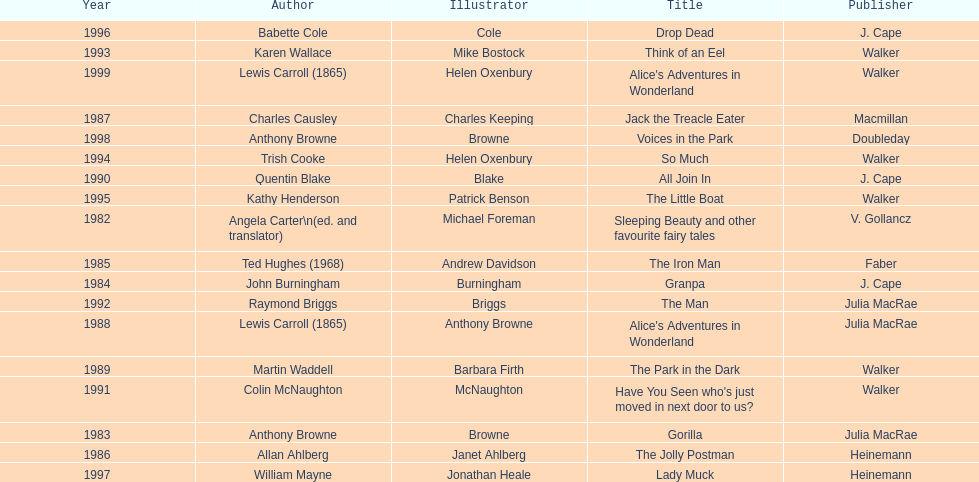Can you parse all the data within this table? {'header': ['Year', 'Author', 'Illustrator', 'Title', 'Publisher'], 'rows': [['1996', 'Babette Cole', 'Cole', 'Drop Dead', 'J. Cape'], ['1993', 'Karen Wallace', 'Mike Bostock', 'Think of an Eel', 'Walker'], ['1999', 'Lewis Carroll (1865)', 'Helen Oxenbury', "Alice's Adventures in Wonderland", 'Walker'], ['1987', 'Charles Causley', 'Charles Keeping', 'Jack the Treacle Eater', 'Macmillan'], ['1998', 'Anthony Browne', 'Browne', 'Voices in the Park', 'Doubleday'], ['1994', 'Trish Cooke', 'Helen Oxenbury', 'So Much', 'Walker'], ['1990', 'Quentin Blake', 'Blake', 'All Join In', 'J. Cape'], ['1995', 'Kathy Henderson', 'Patrick Benson', 'The Little Boat', 'Walker'], ['1982', 'Angela Carter\\n(ed. and translator)', 'Michael Foreman', 'Sleeping Beauty and other favourite fairy tales', 'V. Gollancz'], ['1985', 'Ted Hughes (1968)', 'Andrew Davidson', 'The Iron Man', 'Faber'], ['1984', 'John Burningham', 'Burningham', 'Granpa', 'J. Cape'], ['1992', 'Raymond Briggs', 'Briggs', 'The Man', 'Julia MacRae'], ['1988', 'Lewis Carroll (1865)', 'Anthony Browne', "Alice's Adventures in Wonderland", 'Julia MacRae'], ['1989', 'Martin Waddell', 'Barbara Firth', 'The Park in the Dark', 'Walker'], ['1991', 'Colin McNaughton', 'McNaughton', "Have You Seen who's just moved in next door to us?", 'Walker'], ['1983', 'Anthony Browne', 'Browne', 'Gorilla', 'Julia MacRae'], ['1986', 'Allan Ahlberg', 'Janet Ahlberg', 'The Jolly Postman', 'Heinemann'], ['1997', 'William Mayne', 'Jonathan Heale', 'Lady Muck', 'Heinemann']]} Which other author, besides lewis carroll, has won the kurt maschler award twice? Anthony Browne. 